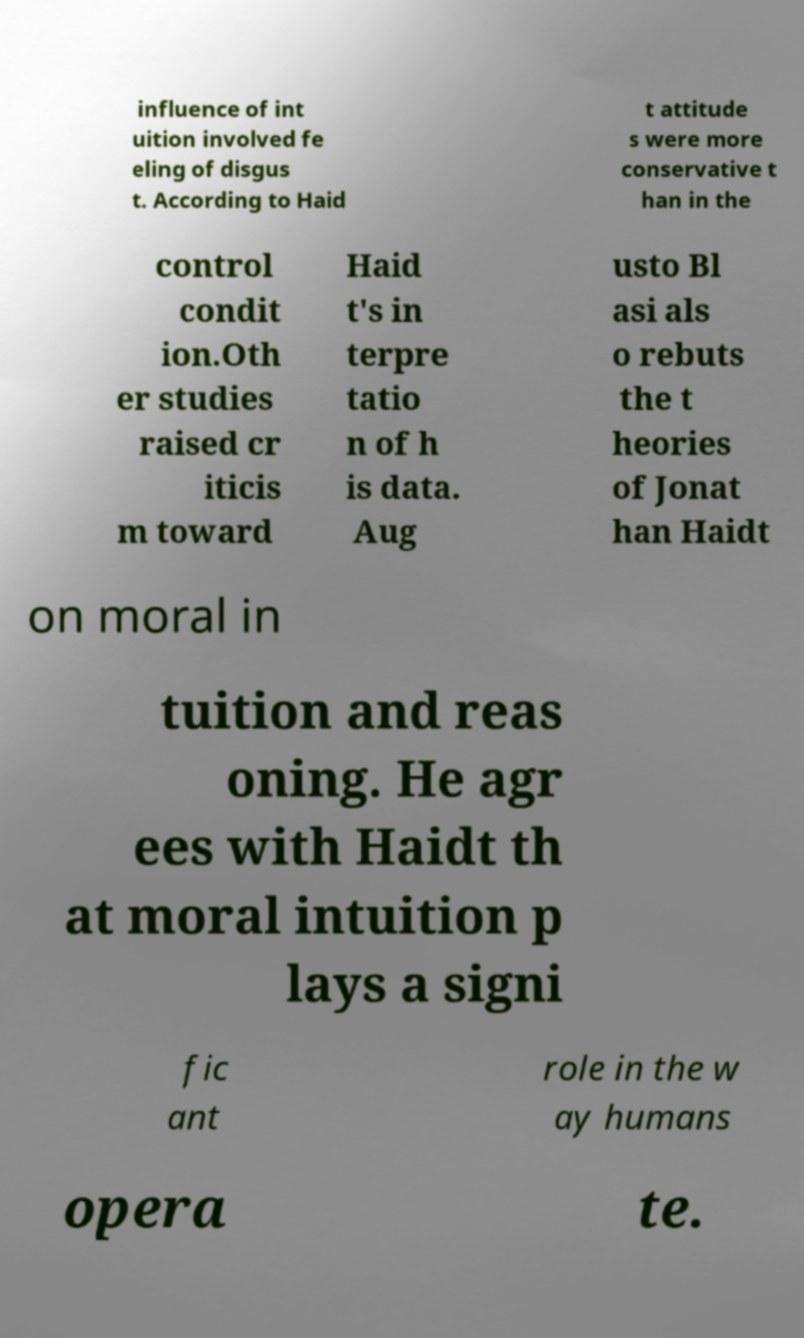What messages or text are displayed in this image? I need them in a readable, typed format. influence of int uition involved fe eling of disgus t. According to Haid t attitude s were more conservative t han in the control condit ion.Oth er studies raised cr iticis m toward Haid t's in terpre tatio n of h is data. Aug usto Bl asi als o rebuts the t heories of Jonat han Haidt on moral in tuition and reas oning. He agr ees with Haidt th at moral intuition p lays a signi fic ant role in the w ay humans opera te. 